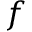<formula> <loc_0><loc_0><loc_500><loc_500>f</formula> 